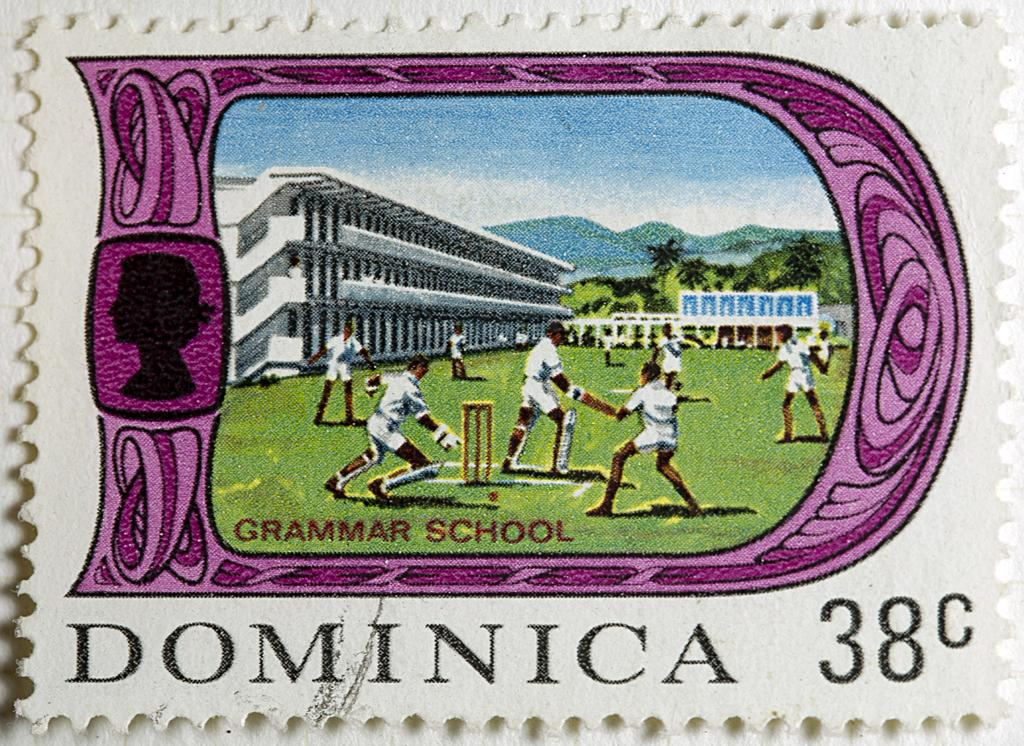<image>
Share a concise interpretation of the image provided. A stamp from Dominica for 38 cents with Grammar School on it 